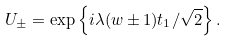<formula> <loc_0><loc_0><loc_500><loc_500>U _ { \pm } = \exp \left \{ i \lambda ( w \pm 1 ) { t } _ { 1 } / \sqrt { 2 } \right \} .</formula> 